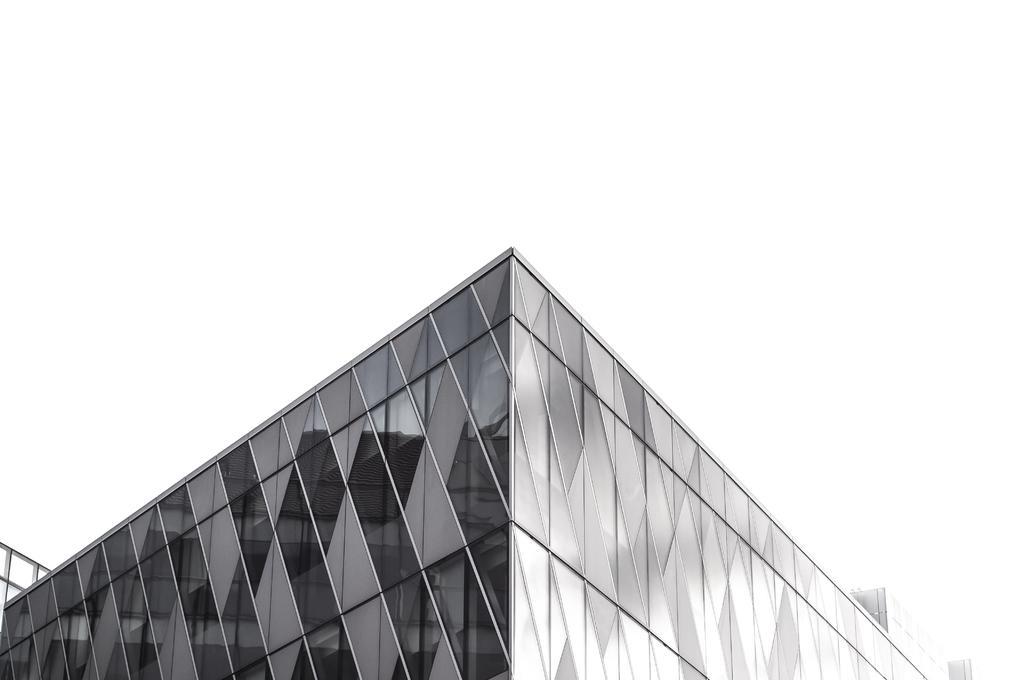Could you give a brief overview of what you see in this image? This image is a black and white image. This image is taken outdoors. In this image there is a building. 